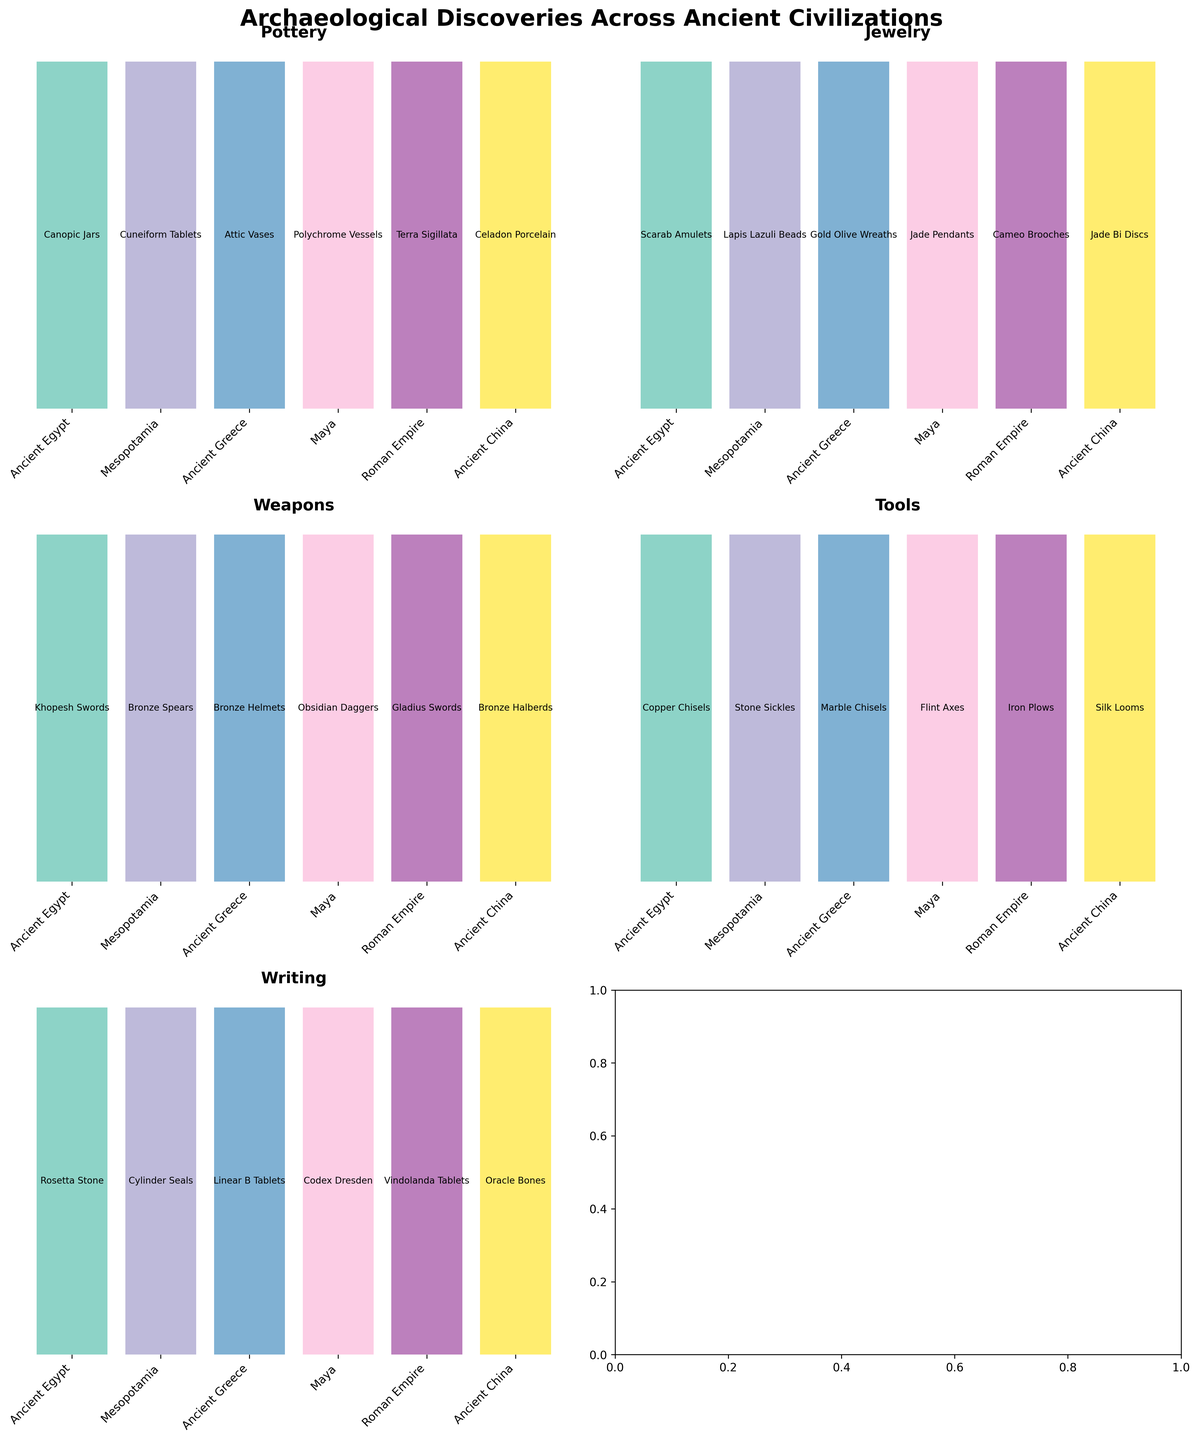What is the title of the overall figure? The title is displayed at the top of the figure and reads "Archaeological Discoveries Across Ancient Civilizations".
Answer: Archaeological Discoveries Across Ancient Civilizations How many ancient civilizations are represented in the figure? The figure displays several subplots, each one listing names of ancient civilizations as bar labels. By counting them, we see there are six civilizations.
Answer: Six Which civilization is associated with the 'Khopesh Swords'? To find which civilization is associated with 'Khopesh Swords', look at the subplot for 'Weapons' and scan for 'Khopesh Swords' among the labels. It is associated with 'Ancient Egypt'.
Answer: Ancient Egypt Name all artifact types shown in the figure. The artifact types are indicated by the titles of each subplot within the figure: Pottery, Jewelry, Weapons, Tools, and Writing.
Answer: Pottery, Jewelry, Weapons, Tools, Writing Which three artifacts are listed under the civilization associated with the 'Codex Dresden'? Find the civilization 'Maya' (associated with 'Codex Dresden' in the 'Writing' subplot) and then check other subplots for their respective artifacts: 'Polychrome Vessels' (Pottery), 'Jade Pendants' (Jewelry), and 'Obsidian Daggers' (Weapons).
Answer: Polychrome Vessels, Jade Pendants, Obsidian Daggers Which civilization is linked with 'Gold Olive Wreaths', and what is their writing artifact? Locate 'Gold Olive Wreaths' in the 'Jewelry' subplot, then find the corresponding civilization 'Ancient Greece'. Next, identify the writing artifact listed for Ancient Greece, which is 'Linear B Tablets'.
Answer: Ancient Greece, Linear B Tablets Are the 'Cuneiform Tablets' listed under the same civilization as the 'Cylinder Seals' or 'Lapis Lazuli Beads'? To answer this, find 'Cuneiform Tablets' in the 'Pottery' subplot and note the civilization 'Mesopotamia'. Then, verify that both 'Cylinder Seals' in the 'Writing' subplot and 'Lapis Lazuli Beads' in the 'Jewelry' subplot are listed under the same civilization.
Answer: Same civilization Which tools are listed under the civilization with 'Celadon Porcelain'? Identify the civilization 'Ancient China' associated with 'Celadon Porcelain' in the 'Pottery' subplot, and then look for the tools listed under this civilization, which are 'Silk Looms'.
Answer: Silk Looms Count the number of unique artifact types listed under 'Ancient Greece'. For Ancient Greece, verify the number of unique artifact types by checking each subplot and listing their artifacts: 'Attic Vases' (Pottery), 'Gold Olive Wreaths' (Jewelry), 'Bronze Helmets' (Weapons), 'Marble Chisels' (Tools), and 'Linear B Tablets' (Writing). Count all artifacts without repetition.
Answer: Five Which civilization has the same artifact type for 'Scarab Amulets' and what are its artifacts listed in the same positions? To find the corresponding positions, locate 'Scarab Amulets' in the 'Jewelry' subplot and note 'Ancient Egypt'. Then compare its artifact listings in the other subplots.
Answer: Ancient Egypt, Canopic Jars (Pottery), Khopesh Swords (Weapons), Copper Chisels (Tools), Rosetta Stone (Writing) 